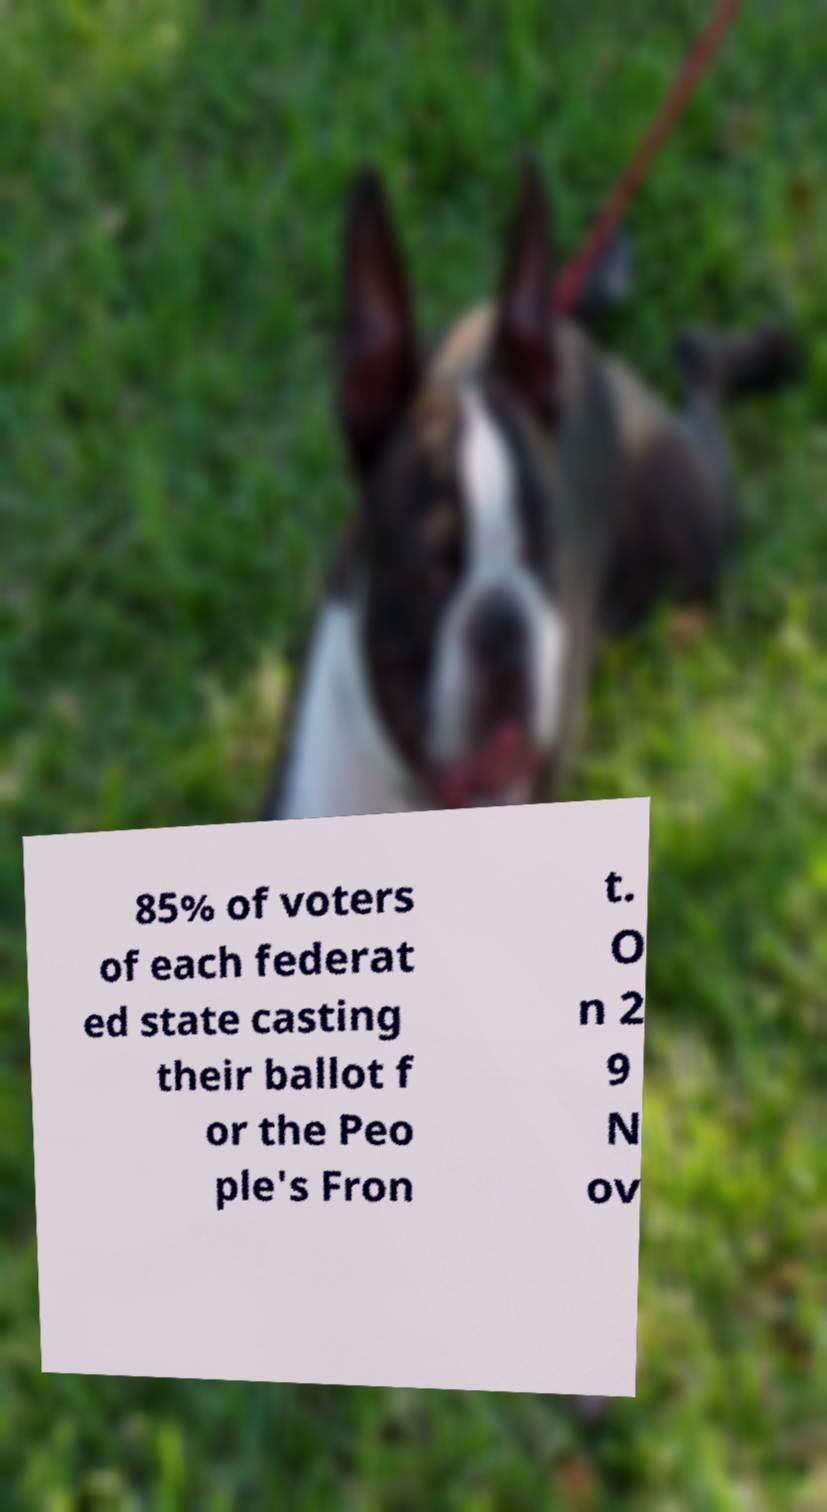What messages or text are displayed in this image? I need them in a readable, typed format. 85% of voters of each federat ed state casting their ballot f or the Peo ple's Fron t. O n 2 9 N ov 